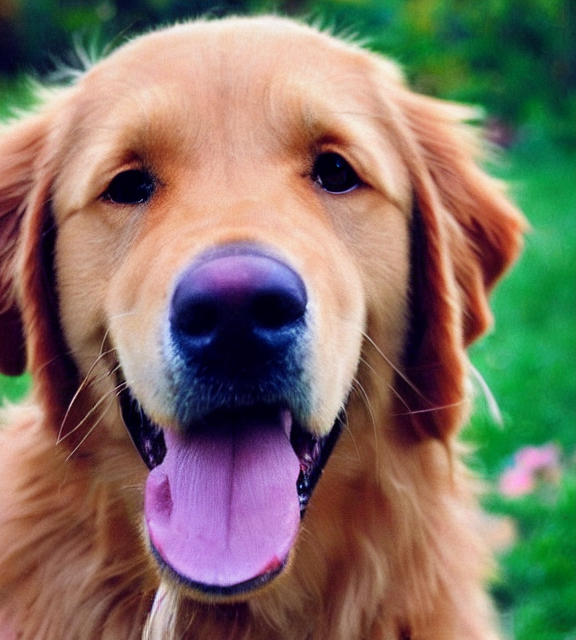Is there any noise present in the image? The image appears crisp and clear without any visible noise disrupting the quality. 